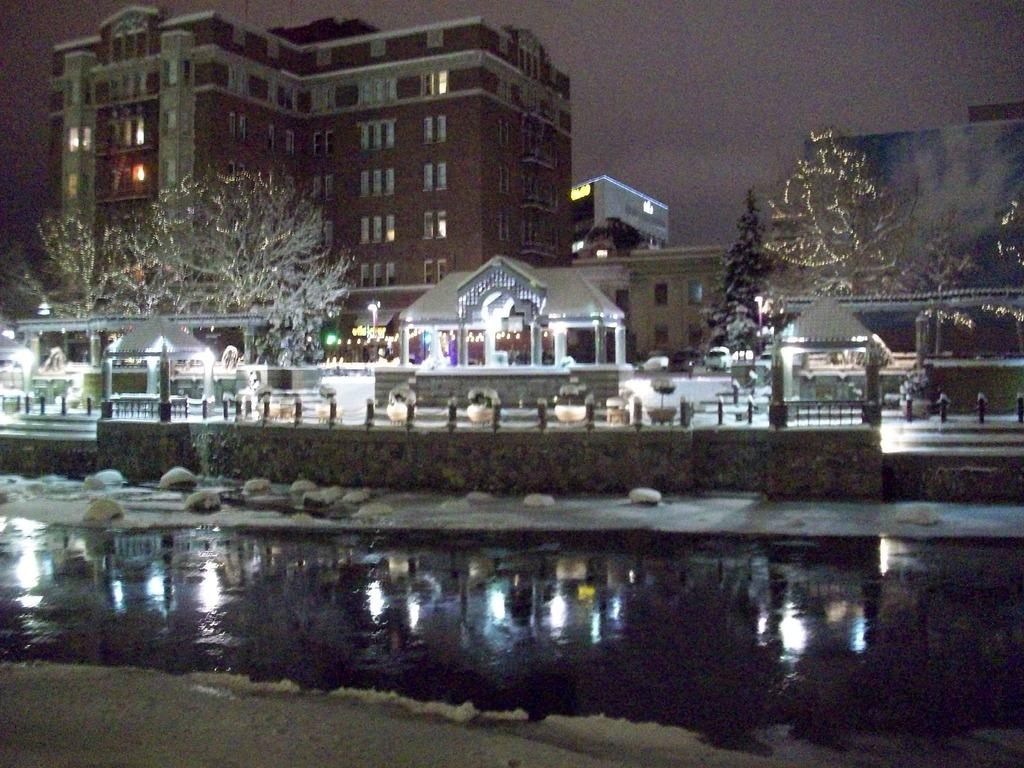What type of structures can be seen in the image? There are buildings in the image. What natural elements are present in the image? There are trees in the image. What type of illumination is visible in the image? There are lights in the image. What type of seating is available in the image? There are benches in the image. What type of vertical structures are present in the image? There are poles in the image. What type of body of water is visible in the image? There is water visible in the image. What can be seen in the background of the image? The sky is visible in the background of the image. How many mountains are visible in the image? There are no mountains visible in the image. What is the size of the parcel of land in the image? There is no specific parcel of land mentioned in the image, so it is impossible to determine its size. 